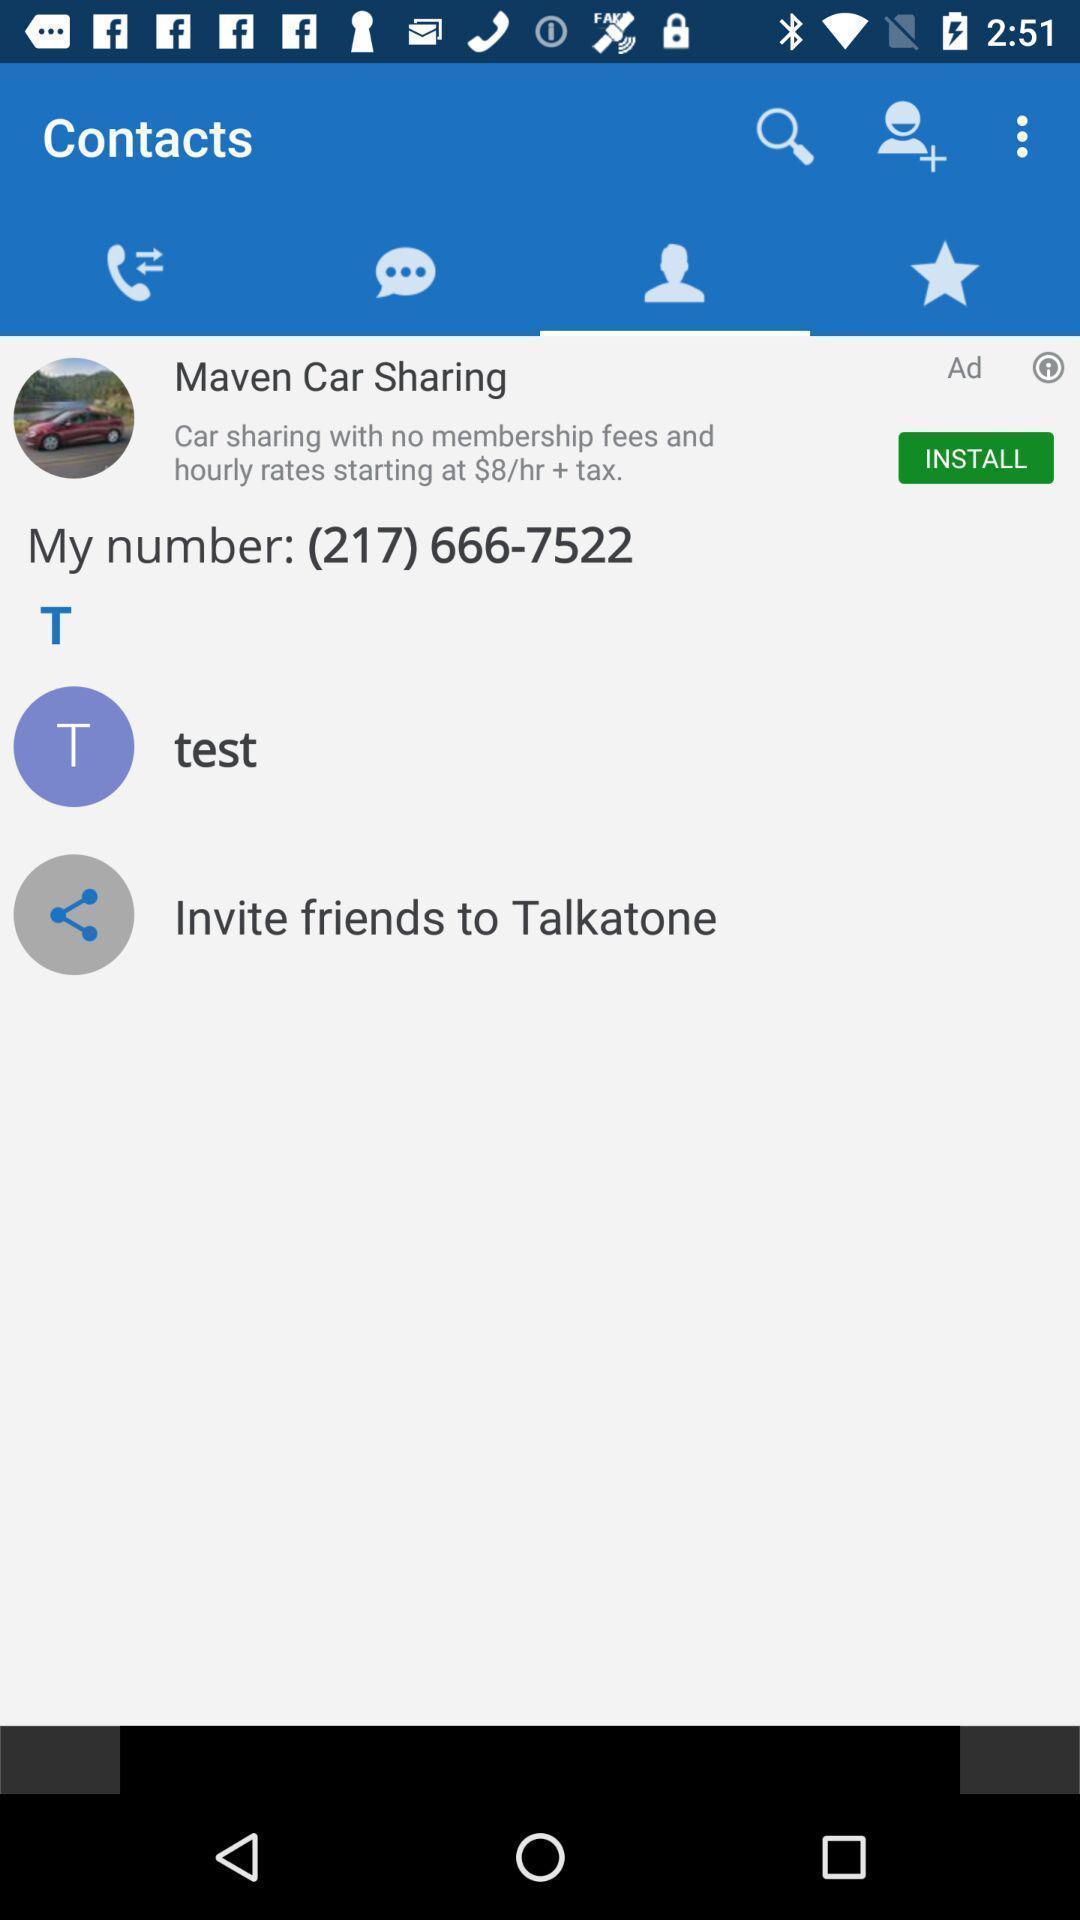Describe the key features of this screenshot. Page showing your contact list. 